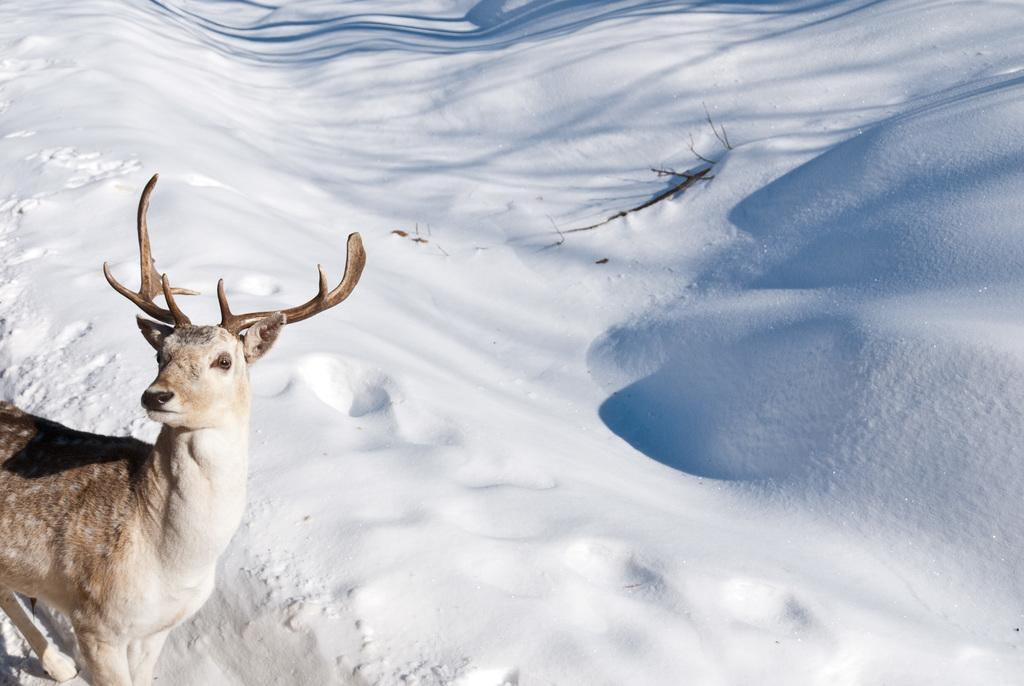What type of creature is in the picture? There is an animal in the picture. How is the animal positioned in the image? The animal is standing. What can be seen in the background of the image? There is snow in the background of the image. What type of exchange is taking place between the women in the image? There are no women present in the image, and no exchange is taking place. Can you tell me which chess piece the animal is representing in the image? The image does not depict a game of chess, and there is no indication of any chess pieces. 